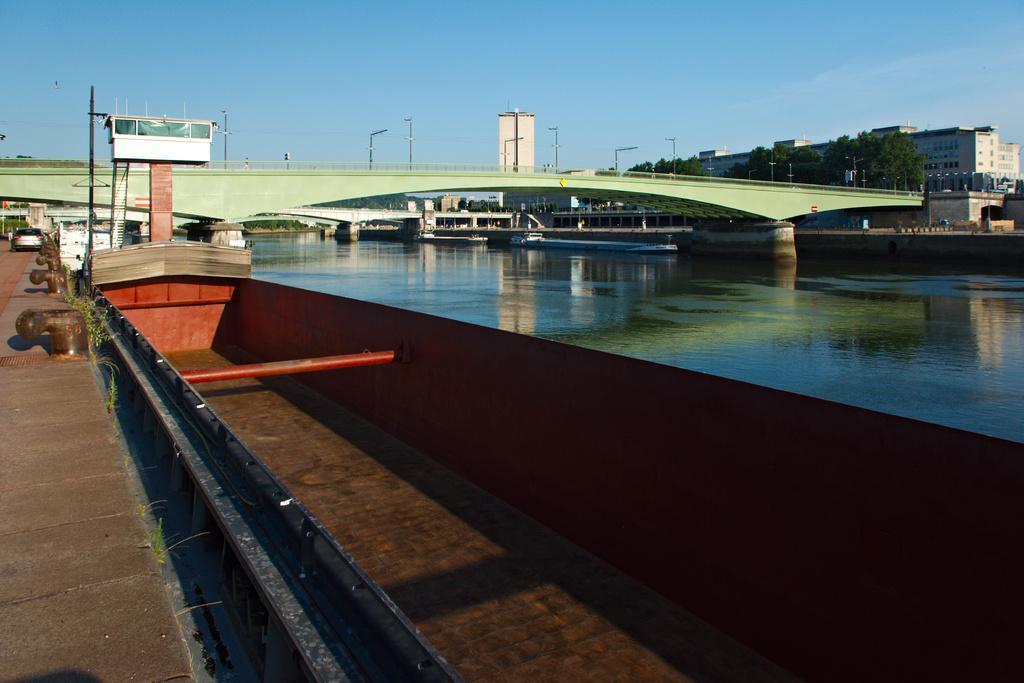Describe this image in one or two sentences. In this picture I can see the water, above that I can see two bridges. On the left there is a car which is parked near to the fencing and pole. On the right I can see many buildings, street lights, fencing, flags and trees. At the top I can see the sky and clouds. At the bottom there is a boat. 